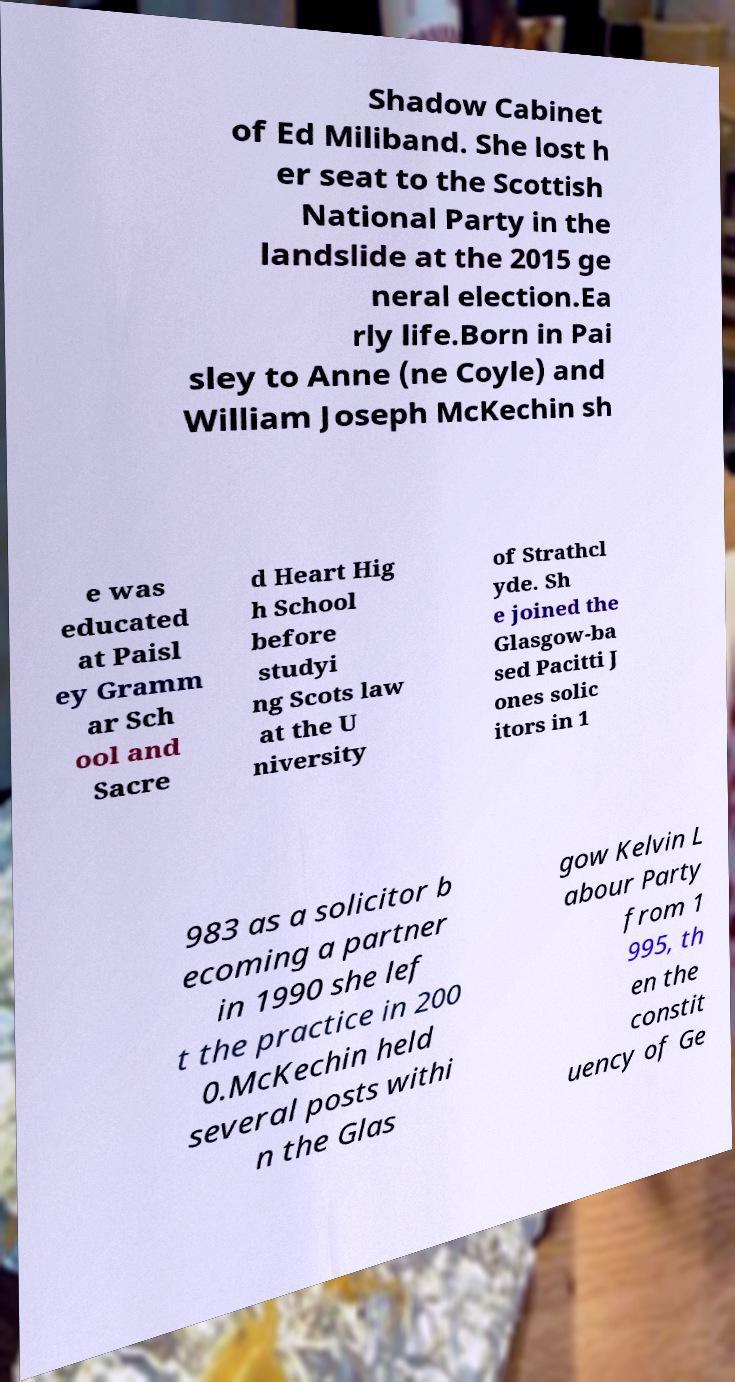What messages or text are displayed in this image? I need them in a readable, typed format. Shadow Cabinet of Ed Miliband. She lost h er seat to the Scottish National Party in the landslide at the 2015 ge neral election.Ea rly life.Born in Pai sley to Anne (ne Coyle) and William Joseph McKechin sh e was educated at Paisl ey Gramm ar Sch ool and Sacre d Heart Hig h School before studyi ng Scots law at the U niversity of Strathcl yde. Sh e joined the Glasgow-ba sed Pacitti J ones solic itors in 1 983 as a solicitor b ecoming a partner in 1990 she lef t the practice in 200 0.McKechin held several posts withi n the Glas gow Kelvin L abour Party from 1 995, th en the constit uency of Ge 